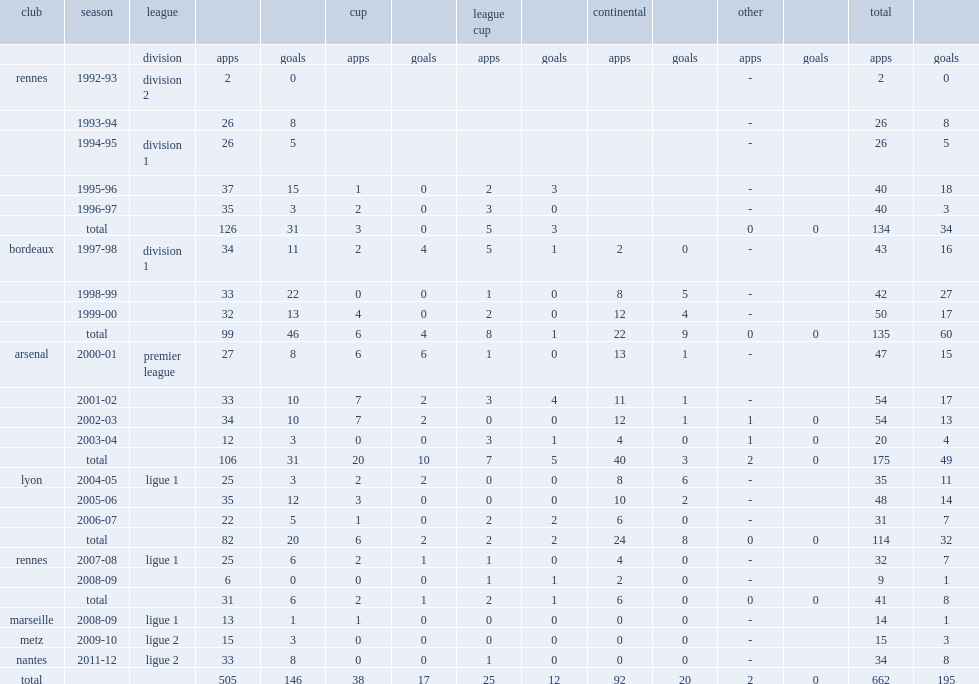Parse the table in full. {'header': ['club', 'season', 'league', '', '', 'cup', '', 'league cup', '', 'continental', '', 'other', '', 'total', ''], 'rows': [['', '', 'division', 'apps', 'goals', 'apps', 'goals', 'apps', 'goals', 'apps', 'goals', 'apps', 'goals', 'apps', 'goals'], ['rennes', '1992-93', 'division 2', '2', '0', '', '', '', '', '', '', '-', '', '2', '0'], ['', '1993-94', '', '26', '8', '', '', '', '', '', '', '-', '', '26', '8'], ['', '1994-95', 'division 1', '26', '5', '', '', '', '', '', '', '-', '', '26', '5'], ['', '1995-96', '', '37', '15', '1', '0', '2', '3', '', '', '-', '', '40', '18'], ['', '1996-97', '', '35', '3', '2', '0', '3', '0', '', '', '-', '', '40', '3'], ['', 'total', '', '126', '31', '3', '0', '5', '3', '', '', '0', '0', '134', '34'], ['bordeaux', '1997-98', 'division 1', '34', '11', '2', '4', '5', '1', '2', '0', '-', '', '43', '16'], ['', '1998-99', '', '33', '22', '0', '0', '1', '0', '8', '5', '-', '', '42', '27'], ['', '1999-00', '', '32', '13', '4', '0', '2', '0', '12', '4', '-', '', '50', '17'], ['', 'total', '', '99', '46', '6', '4', '8', '1', '22', '9', '0', '0', '135', '60'], ['arsenal', '2000-01', 'premier league', '27', '8', '6', '6', '1', '0', '13', '1', '-', '', '47', '15'], ['', '2001-02', '', '33', '10', '7', '2', '3', '4', '11', '1', '-', '', '54', '17'], ['', '2002-03', '', '34', '10', '7', '2', '0', '0', '12', '1', '1', '0', '54', '13'], ['', '2003-04', '', '12', '3', '0', '0', '3', '1', '4', '0', '1', '0', '20', '4'], ['', 'total', '', '106', '31', '20', '10', '7', '5', '40', '3', '2', '0', '175', '49'], ['lyon', '2004-05', 'ligue 1', '25', '3', '2', '2', '0', '0', '8', '6', '-', '', '35', '11'], ['', '2005-06', '', '35', '12', '3', '0', '0', '0', '10', '2', '-', '', '48', '14'], ['', '2006-07', '', '22', '5', '1', '0', '2', '2', '6', '0', '-', '', '31', '7'], ['', 'total', '', '82', '20', '6', '2', '2', '2', '24', '8', '0', '0', '114', '32'], ['rennes', '2007-08', 'ligue 1', '25', '6', '2', '1', '1', '0', '4', '0', '-', '', '32', '7'], ['', '2008-09', '', '6', '0', '0', '0', '1', '1', '2', '0', '-', '', '9', '1'], ['', 'total', '', '31', '6', '2', '1', '2', '1', '6', '0', '0', '0', '41', '8'], ['marseille', '2008-09', 'ligue 1', '13', '1', '1', '0', '0', '0', '0', '0', '-', '', '14', '1'], ['metz', '2009-10', 'ligue 2', '15', '3', '0', '0', '0', '0', '0', '0', '-', '', '15', '3'], ['nantes', '2011-12', 'ligue 2', '33', '8', '0', '0', '1', '0', '0', '0', '-', '', '34', '8'], ['total', '', '', '505', '146', '38', '17', '25', '12', '92', '20', '2', '0', '662', '195']]} In 2001-02, which league did sylvain wiltord appear for arsenal? Premier league. 